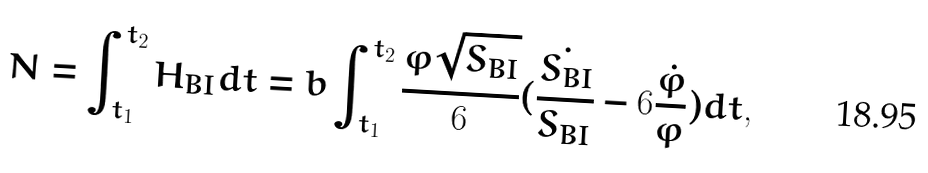Convert formula to latex. <formula><loc_0><loc_0><loc_500><loc_500>N = \int _ { t _ { 1 } } ^ { t _ { 2 } } H _ { B I } d t = b \int _ { t _ { 1 } } ^ { t _ { 2 } } { \frac { \varphi \sqrt { S _ { B I } } } { 6 } ( \frac { \dot { S _ { B I } } } { S _ { B I } } - 6 \frac { \dot { \varphi } } { \varphi } ) } d t ,</formula> 